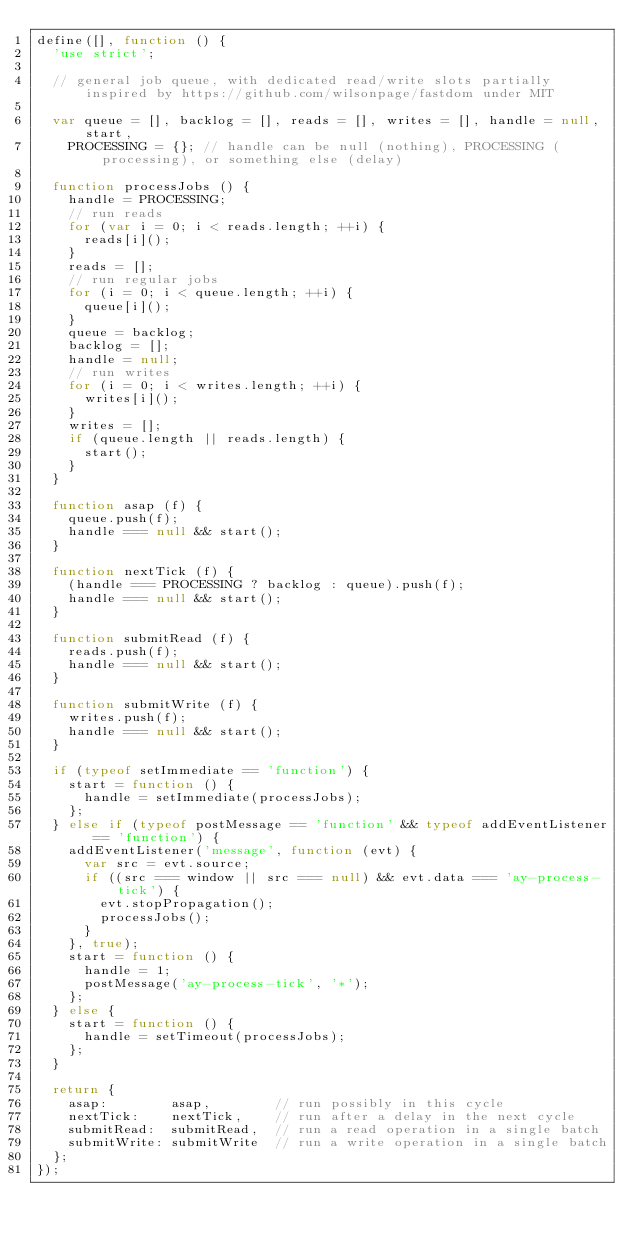<code> <loc_0><loc_0><loc_500><loc_500><_JavaScript_>define([], function () {
	'use strict';

	// general job queue, with dedicated read/write slots partially inspired by https://github.com/wilsonpage/fastdom under MIT

	var queue = [], backlog = [], reads = [], writes = [], handle = null, start,
		PROCESSING = {}; // handle can be null (nothing), PROCESSING (processing), or something else (delay)

	function processJobs () {
		handle = PROCESSING;
		// run reads
		for (var i = 0; i < reads.length; ++i) {
			reads[i]();
		}
		reads = [];
		// run regular jobs
		for (i = 0; i < queue.length; ++i) {
			queue[i]();
		}
		queue = backlog;
		backlog = [];
		handle = null;
		// run writes
		for (i = 0; i < writes.length; ++i) {
			writes[i]();
		}
		writes = [];
		if (queue.length || reads.length) {
			start();
		}
	}

	function asap (f) {
		queue.push(f);
		handle === null && start();
	}

	function nextTick (f) {
		(handle === PROCESSING ? backlog : queue).push(f);
		handle === null && start();
	}

	function submitRead (f) {
		reads.push(f);
		handle === null && start();
	}

	function submitWrite (f) {
		writes.push(f);
		handle === null && start();
	}

	if (typeof setImmediate == 'function') {
		start = function () {
			handle = setImmediate(processJobs);
		};
	} else if (typeof postMessage == 'function' && typeof addEventListener == 'function') {
		addEventListener('message', function (evt) {
			var src = evt.source;
			if ((src === window || src === null) && evt.data === 'ay-process-tick') {
				evt.stopPropagation();
				processJobs();
			}
		}, true);
		start = function () {
			handle = 1;
			postMessage('ay-process-tick', '*');
		};
	} else {
		start = function () {
			handle = setTimeout(processJobs);
		};
	}

	return {
		asap:        asap,        // run possibly in this cycle
		nextTick:    nextTick,    // run after a delay in the next cycle
		submitRead:  submitRead,  // run a read operation in a single batch
		submitWrite: submitWrite  // run a write operation in a single batch
	};
});
</code> 